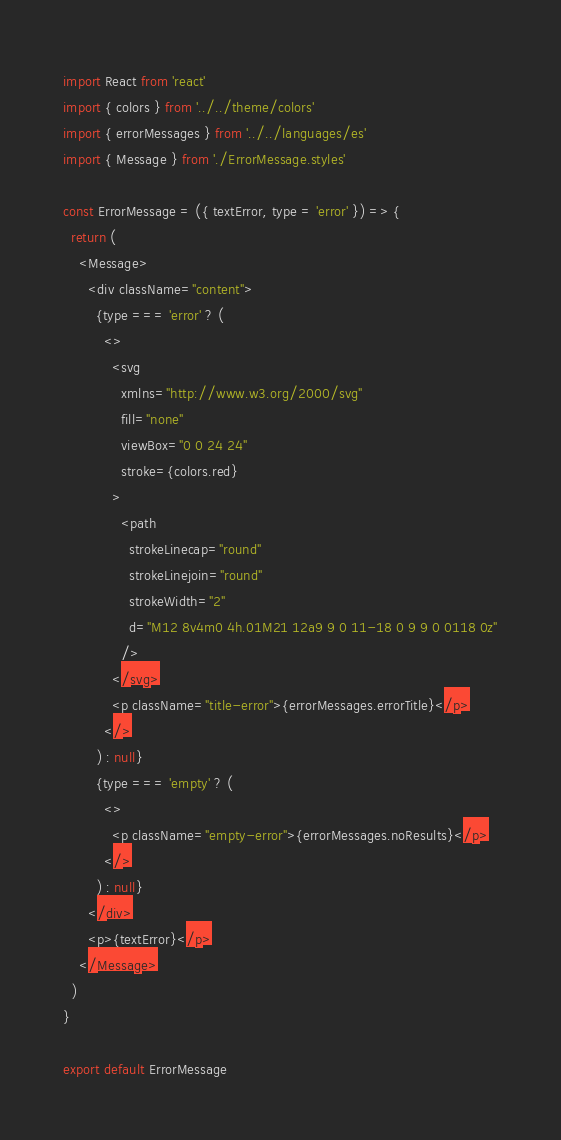Convert code to text. <code><loc_0><loc_0><loc_500><loc_500><_JavaScript_>import React from 'react'
import { colors } from '../../theme/colors'
import { errorMessages } from '../../languages/es'
import { Message } from './ErrorMessage.styles'

const ErrorMessage = ({ textError, type = 'error' }) => {
  return (
    <Message>
      <div className="content">
        {type === 'error' ? (
          <>
            <svg
              xmlns="http://www.w3.org/2000/svg"
              fill="none"
              viewBox="0 0 24 24"
              stroke={colors.red}
            >
              <path
                strokeLinecap="round"
                strokeLinejoin="round"
                strokeWidth="2"
                d="M12 8v4m0 4h.01M21 12a9 9 0 11-18 0 9 9 0 0118 0z"
              />
            </svg>
            <p className="title-error">{errorMessages.errorTitle}</p>
          </>
        ) : null}
        {type === 'empty' ? (
          <>
            <p className="empty-error">{errorMessages.noResults}</p>
          </>
        ) : null}
      </div>
      <p>{textError}</p>
    </Message>
  )
}

export default ErrorMessage
</code> 